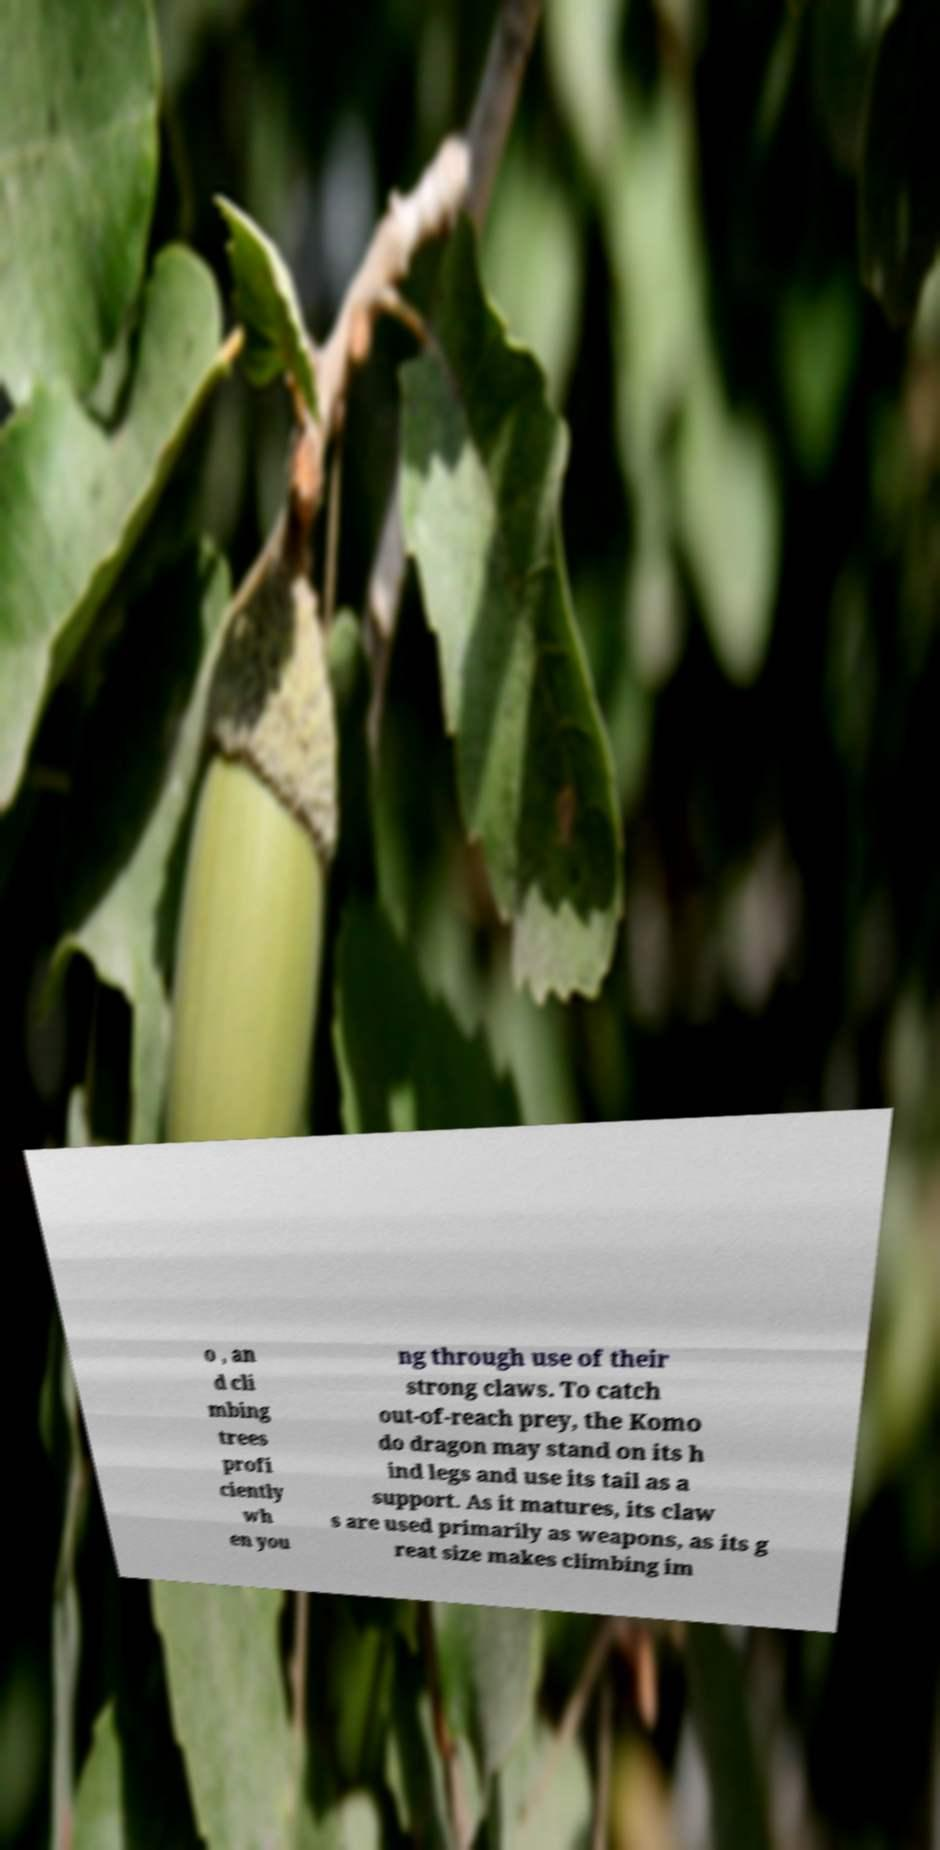Can you accurately transcribe the text from the provided image for me? o , an d cli mbing trees profi ciently wh en you ng through use of their strong claws. To catch out-of-reach prey, the Komo do dragon may stand on its h ind legs and use its tail as a support. As it matures, its claw s are used primarily as weapons, as its g reat size makes climbing im 